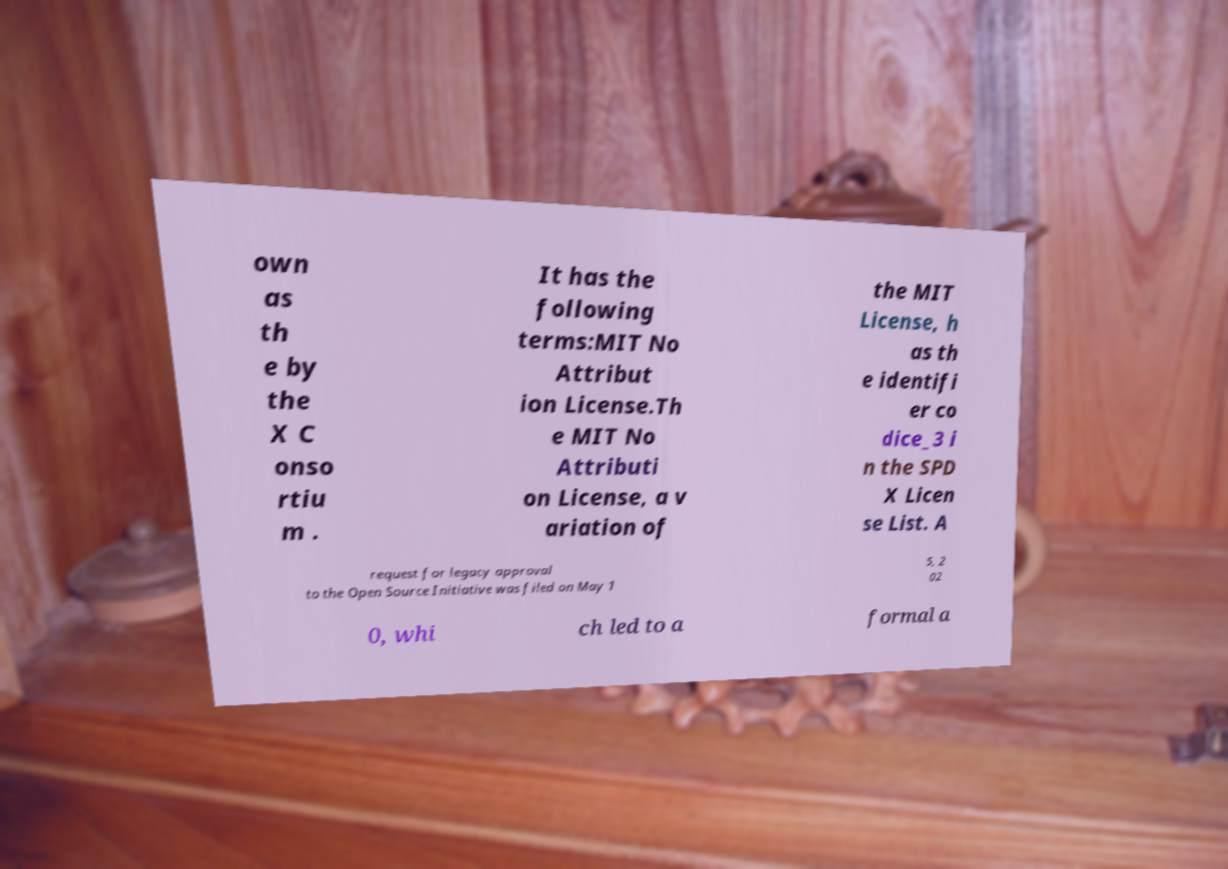I need the written content from this picture converted into text. Can you do that? own as th e by the X C onso rtiu m . It has the following terms:MIT No Attribut ion License.Th e MIT No Attributi on License, a v ariation of the MIT License, h as th e identifi er co dice_3 i n the SPD X Licen se List. A request for legacy approval to the Open Source Initiative was filed on May 1 5, 2 02 0, whi ch led to a formal a 